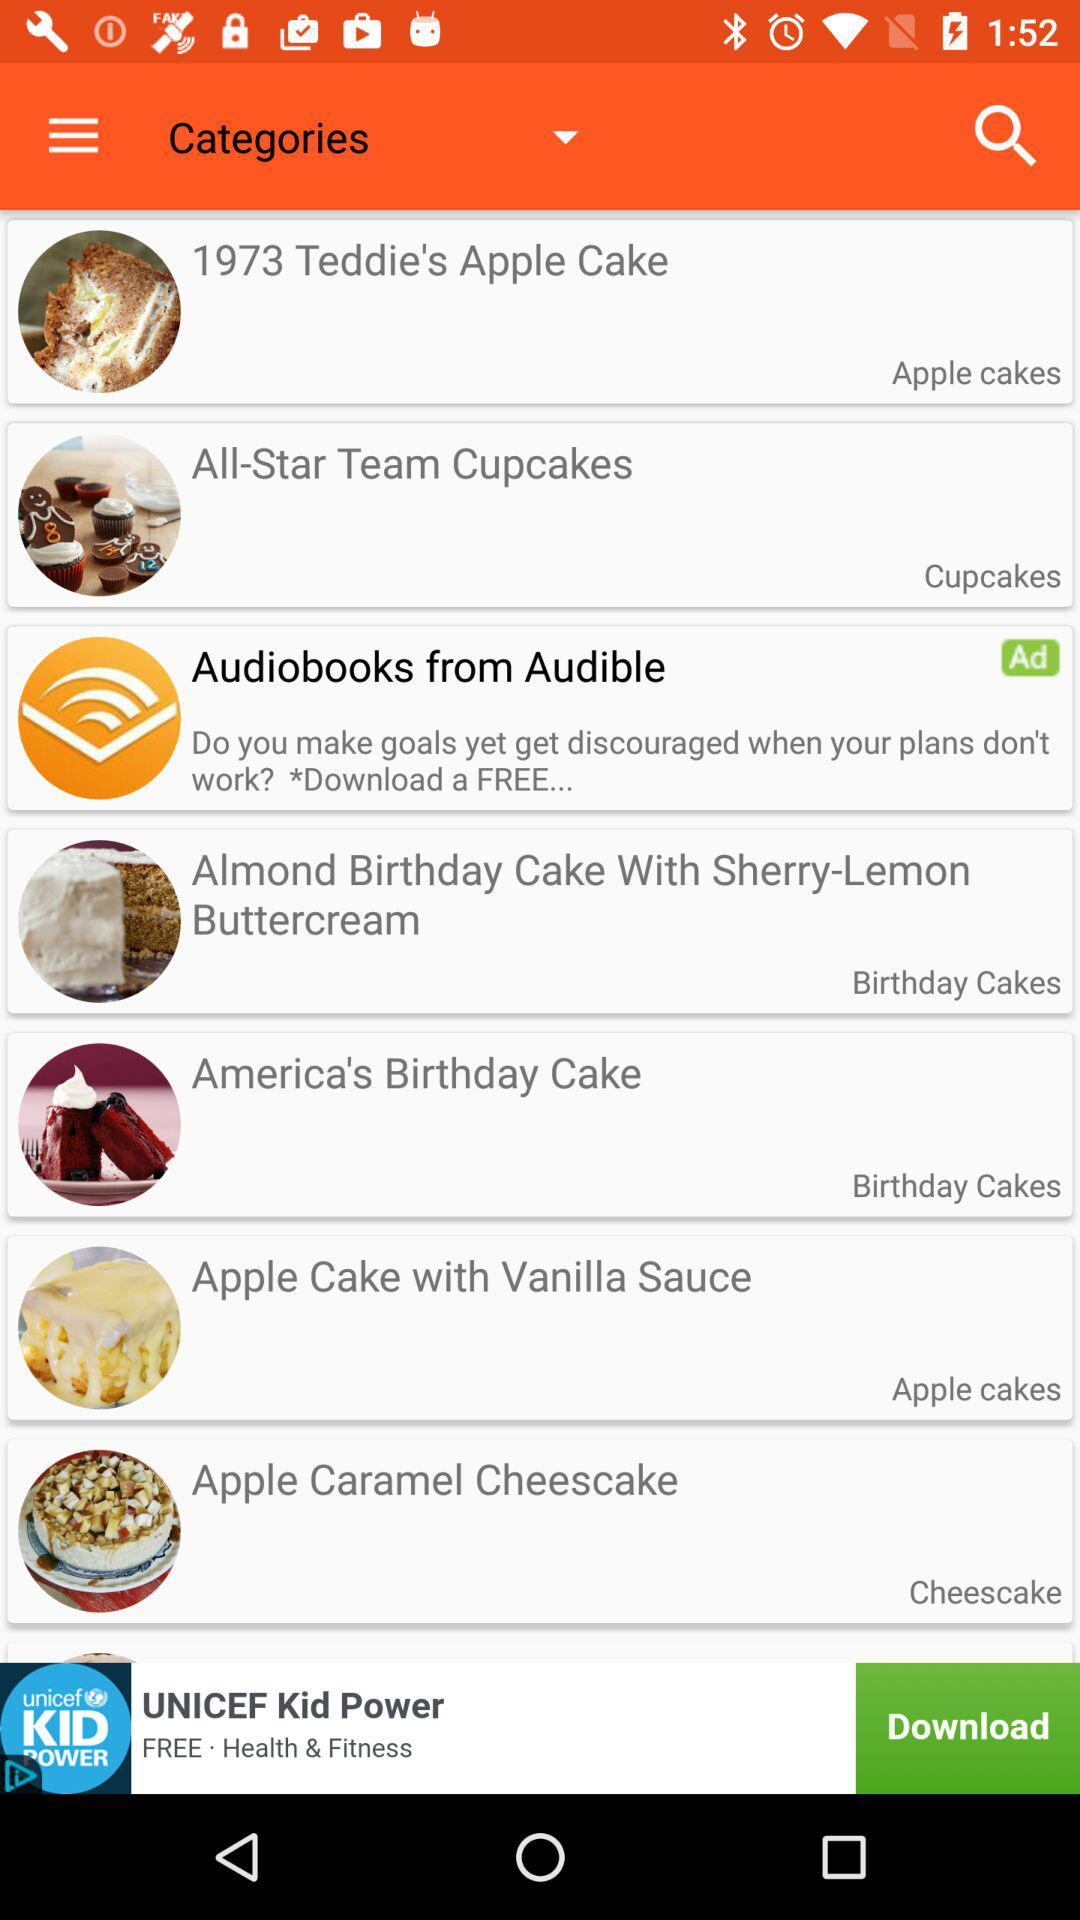What categories are provided? The categories are: "1973 Teddie's Apple Cake", "All-Star Team Cupcakes", "Almond Birthday Cake With Sherry-Lemon Buttercream", "America's Birthday Cake", "Apple Cake With Vanilla Sauce", and "Apple Caramel Cheesecake". 